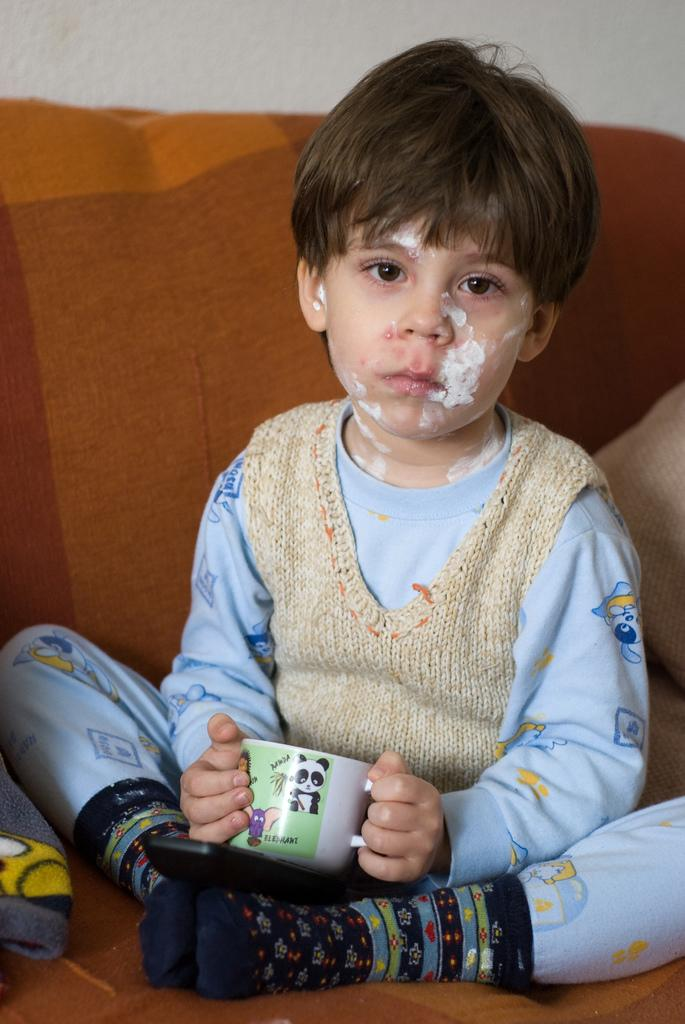What is the main subject of the image? There is a kid in the center of the image. What is the kid doing in the image? The kid is sitting on a sofa. What is the kid holding in the image? The kid is holding a cup. What can be seen in the background of the image? There is a wall visible in the background. How does the kid limit the earthquake in the image? There is no earthquake present in the image, and therefore no such action can be observed. 